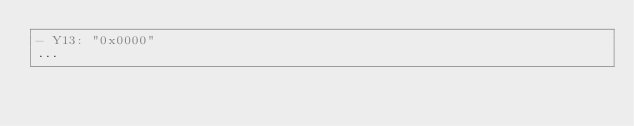Convert code to text. <code><loc_0><loc_0><loc_500><loc_500><_YAML_>- Y13: "0x0000"
...

</code> 